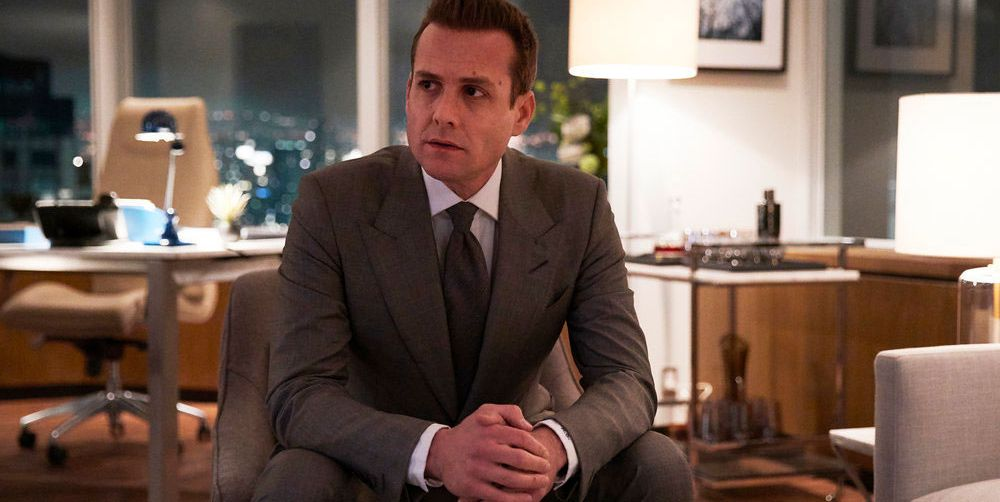Describe the design and layout of the office seen in the image. The office in the image features a modern and sleek aesthetic, with a large wooden desk that has a clean, polished surface. There is an elegant desk lamp that provides a warm, soft glow, enhancing the cozy yet professional atmosphere. The chair and other furnishings are contemporary, with neutral colors that match the overall sober and professional vibe. Large windows on one side of the room offer a stunning view of the city skyline, emphasizing the high-rise nature of the office. This layout not only provides functionality but also exudes a sense of luxury and high-status professionalism. 